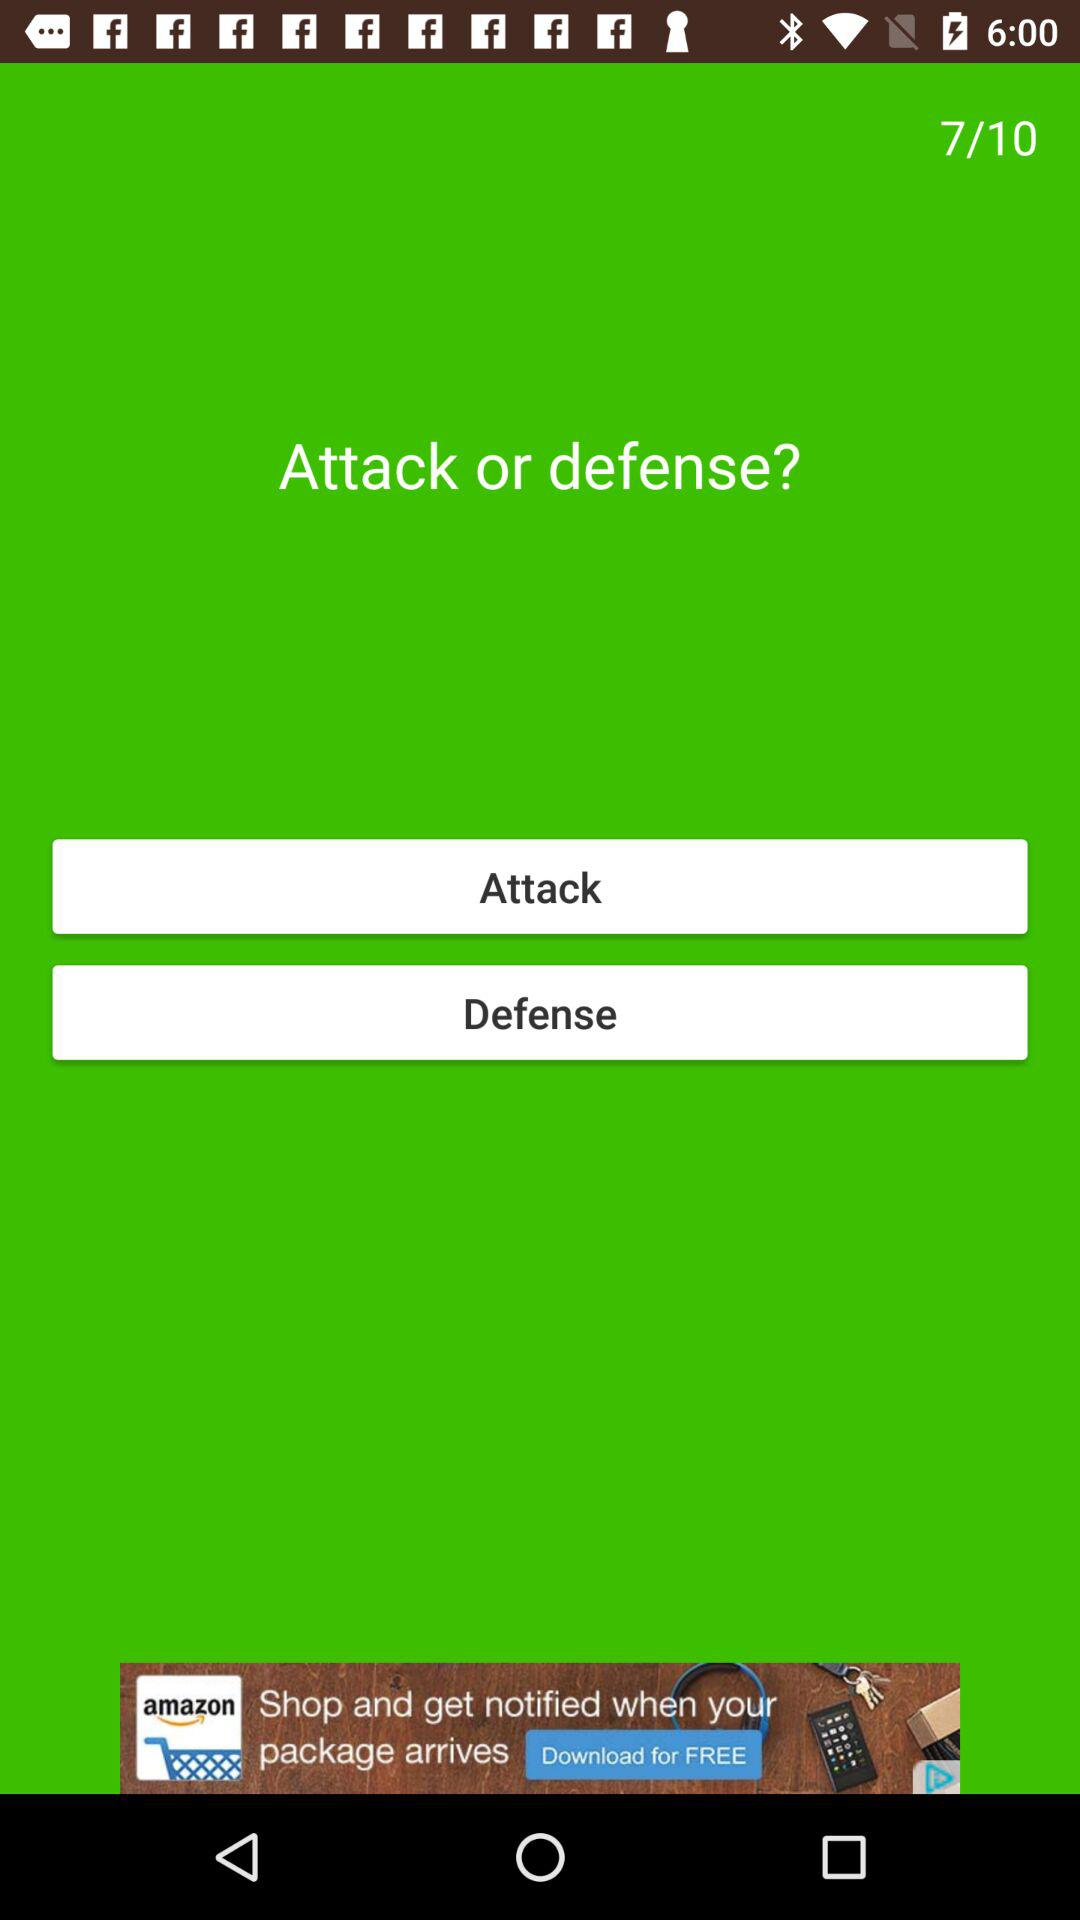What is the current question number? The current question number is 7. 